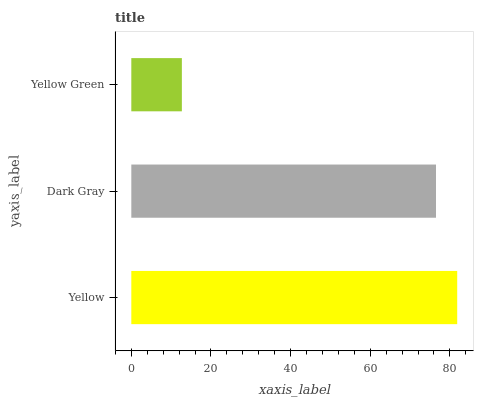Is Yellow Green the minimum?
Answer yes or no. Yes. Is Yellow the maximum?
Answer yes or no. Yes. Is Dark Gray the minimum?
Answer yes or no. No. Is Dark Gray the maximum?
Answer yes or no. No. Is Yellow greater than Dark Gray?
Answer yes or no. Yes. Is Dark Gray less than Yellow?
Answer yes or no. Yes. Is Dark Gray greater than Yellow?
Answer yes or no. No. Is Yellow less than Dark Gray?
Answer yes or no. No. Is Dark Gray the high median?
Answer yes or no. Yes. Is Dark Gray the low median?
Answer yes or no. Yes. Is Yellow the high median?
Answer yes or no. No. Is Yellow Green the low median?
Answer yes or no. No. 